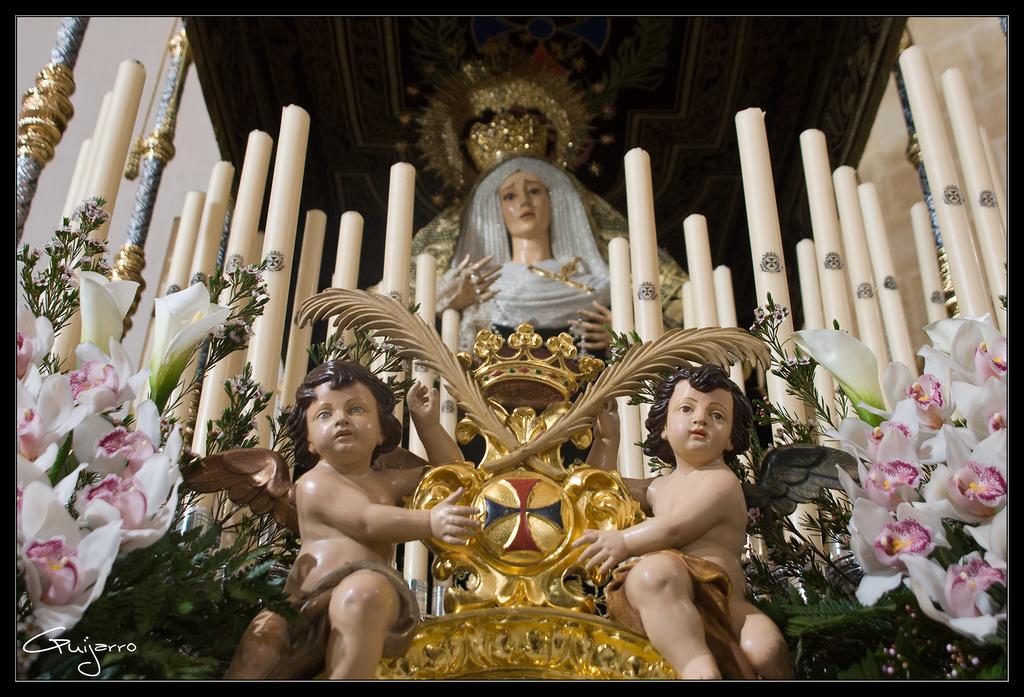Please provide a concise description of this image. In this image there are statues, candles, flowers and leaves, at the top of the image there is chandelier on the rooftop, at the bottom of the image there is some text. 